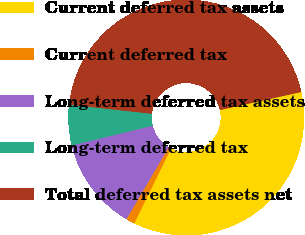<chart> <loc_0><loc_0><loc_500><loc_500><pie_chart><fcel>Current deferred tax assets<fcel>Current deferred tax<fcel>Long-term deferred tax assets<fcel>Long-term deferred tax<fcel>Total deferred tax assets net<nl><fcel>35.75%<fcel>1.19%<fcel>12.73%<fcel>5.55%<fcel>44.78%<nl></chart> 